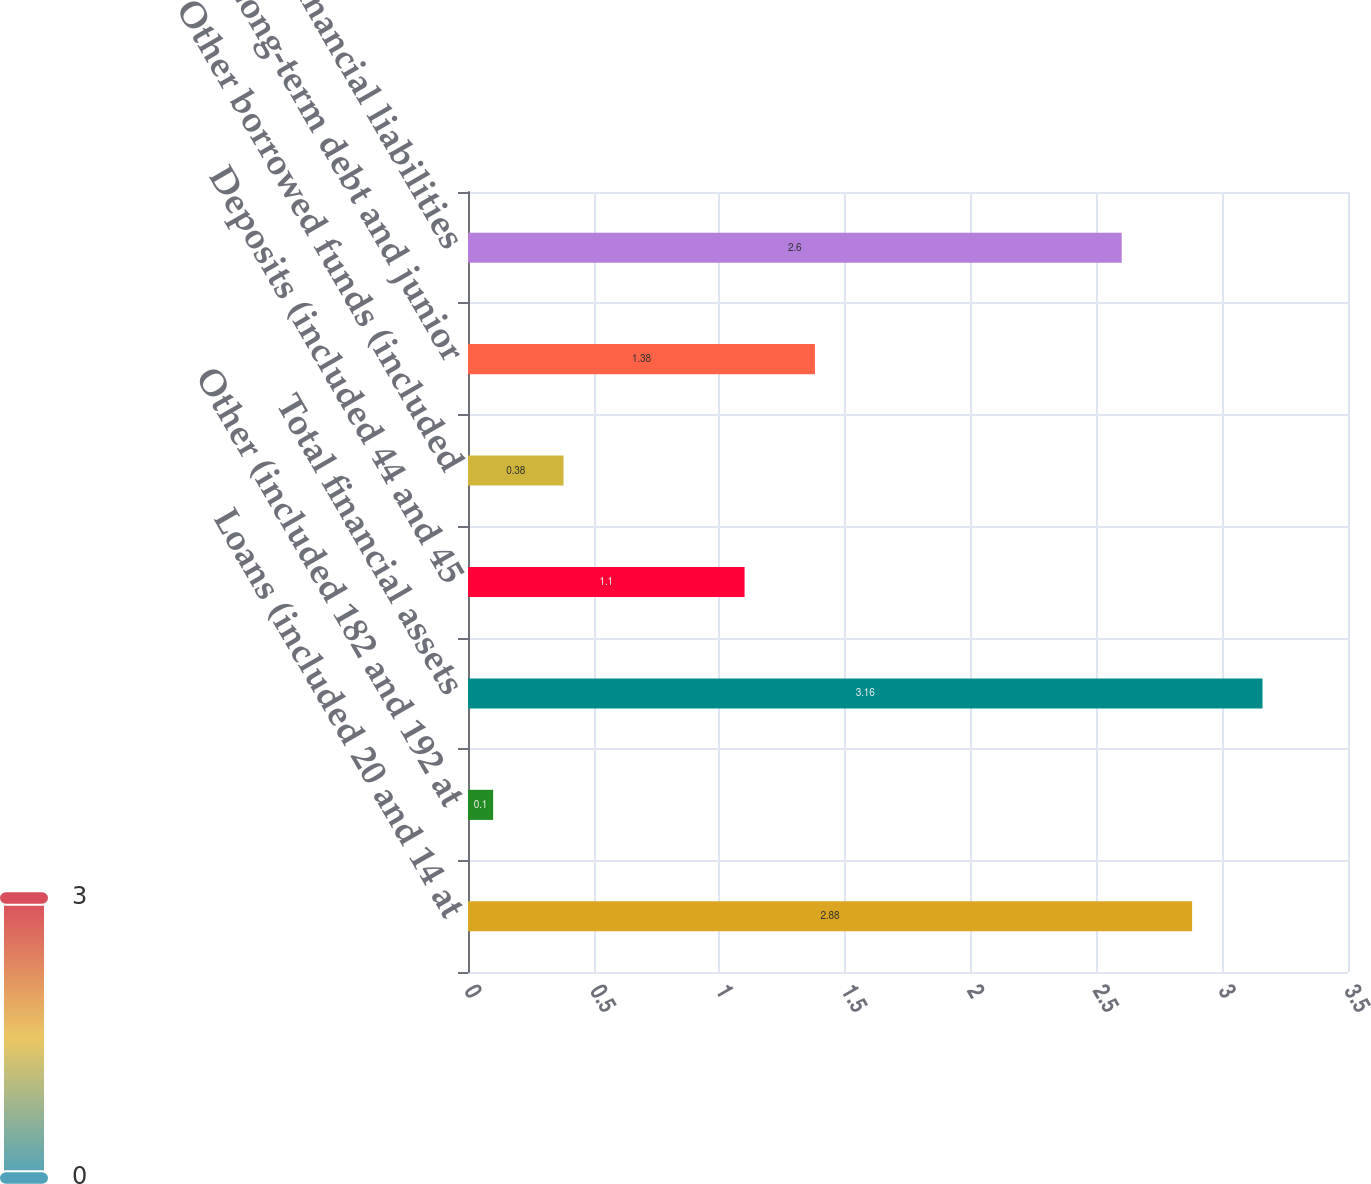Convert chart to OTSL. <chart><loc_0><loc_0><loc_500><loc_500><bar_chart><fcel>Loans (included 20 and 14 at<fcel>Other (included 182 and 192 at<fcel>Total financial assets<fcel>Deposits (included 44 and 45<fcel>Other borrowed funds (included<fcel>Long-term debt and junior<fcel>Total financial liabilities<nl><fcel>2.88<fcel>0.1<fcel>3.16<fcel>1.1<fcel>0.38<fcel>1.38<fcel>2.6<nl></chart> 